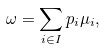Convert formula to latex. <formula><loc_0><loc_0><loc_500><loc_500>\omega = \sum _ { i \in I } p _ { i } \mu _ { i } ,</formula> 